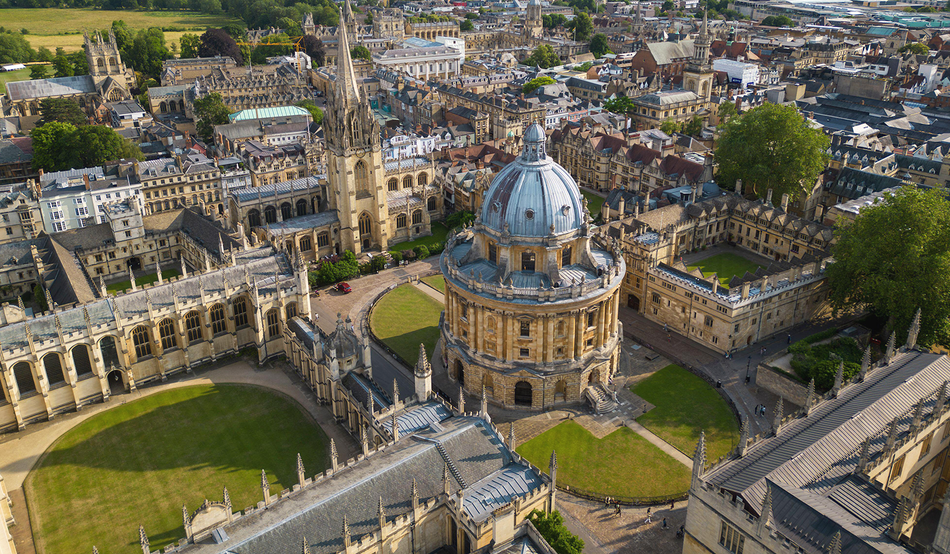Describe the landscape and environment around Oxford University campus as seen in this image. The landscape around Oxford University, as captured in this image, is a blend of meticulously maintained greenery and historic architecture. The courtyards and lawns are immaculately cared for, offering a serene and scholarly atmosphere. Surrounding these spaces are numerous Gothic and Renaissance-style buildings, each contributing to the overall historical and academic ambiance of the area. The layout and landscaping reflect a dedication to preserving the university's rich heritage, creating a peaceful yet intellectually invigorating environment for students and visitors alike. 